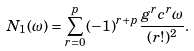Convert formula to latex. <formula><loc_0><loc_0><loc_500><loc_500>N _ { 1 } ( \omega ) = \sum _ { r = 0 } ^ { p } ( - 1 ) ^ { r + p } \frac { g ^ { r } c ^ { r } \omega } { ( r ! ) ^ { 2 } } .</formula> 